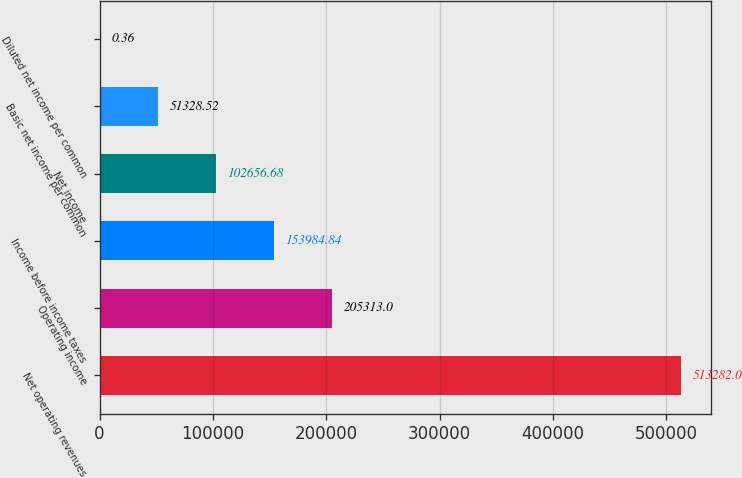Convert chart to OTSL. <chart><loc_0><loc_0><loc_500><loc_500><bar_chart><fcel>Net operating revenues<fcel>Operating income<fcel>Income before income taxes<fcel>Net income<fcel>Basic net income per common<fcel>Diluted net income per common<nl><fcel>513282<fcel>205313<fcel>153985<fcel>102657<fcel>51328.5<fcel>0.36<nl></chart> 